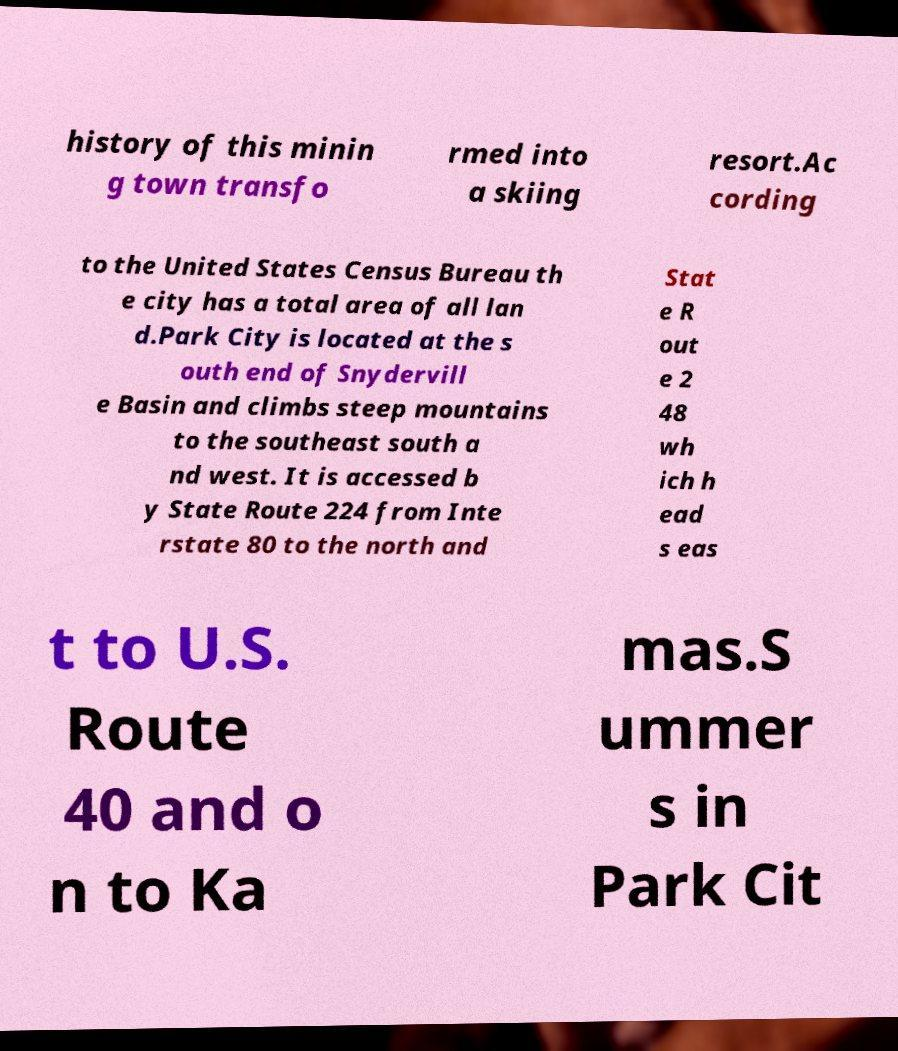Could you extract and type out the text from this image? history of this minin g town transfo rmed into a skiing resort.Ac cording to the United States Census Bureau th e city has a total area of all lan d.Park City is located at the s outh end of Snydervill e Basin and climbs steep mountains to the southeast south a nd west. It is accessed b y State Route 224 from Inte rstate 80 to the north and Stat e R out e 2 48 wh ich h ead s eas t to U.S. Route 40 and o n to Ka mas.S ummer s in Park Cit 